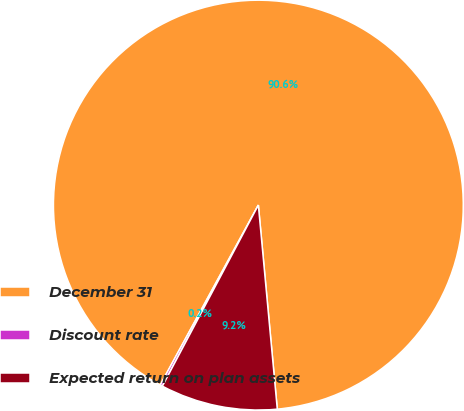<chart> <loc_0><loc_0><loc_500><loc_500><pie_chart><fcel>December 31<fcel>Discount rate<fcel>Expected return on plan assets<nl><fcel>90.58%<fcel>0.19%<fcel>9.23%<nl></chart> 